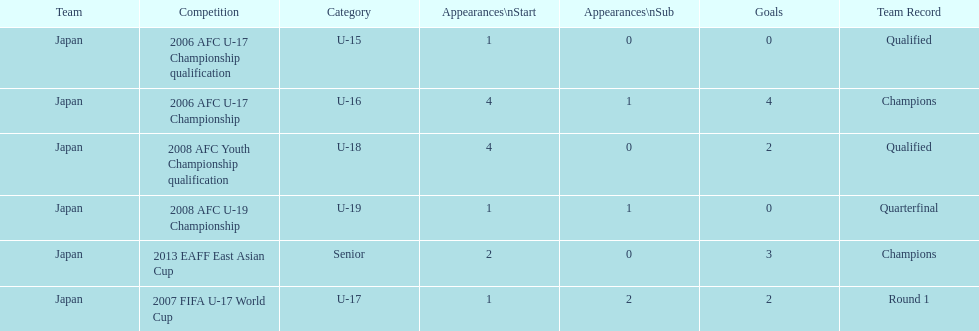What competition did japan compete in 2013? 2013 EAFF East Asian Cup. 